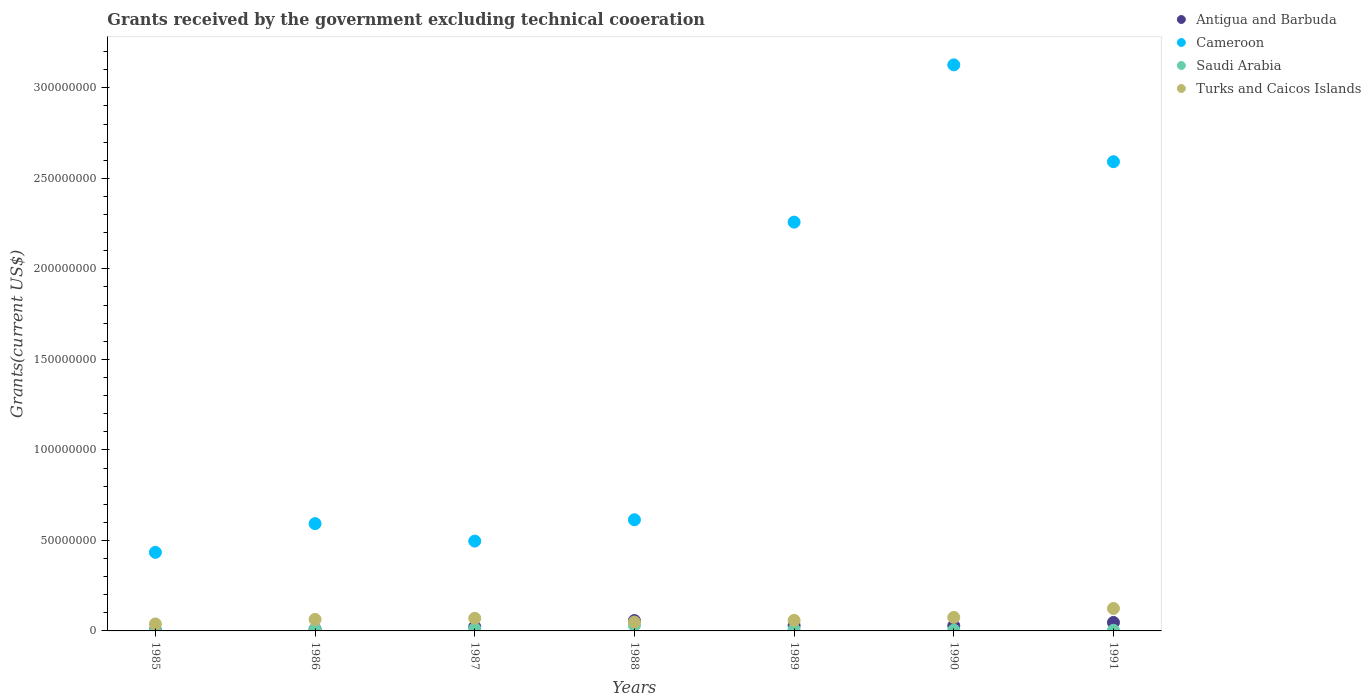How many different coloured dotlines are there?
Ensure brevity in your answer.  4. What is the total grants received by the government in Saudi Arabia in 1987?
Provide a short and direct response. 1.21e+06. Across all years, what is the maximum total grants received by the government in Cameroon?
Give a very brief answer. 3.13e+08. Across all years, what is the minimum total grants received by the government in Saudi Arabia?
Keep it short and to the point. 2.40e+05. In which year was the total grants received by the government in Turks and Caicos Islands minimum?
Offer a terse response. 1985. What is the total total grants received by the government in Saudi Arabia in the graph?
Make the answer very short. 6.97e+06. What is the difference between the total grants received by the government in Antigua and Barbuda in 1985 and that in 1990?
Your response must be concise. -2.38e+06. What is the difference between the total grants received by the government in Turks and Caicos Islands in 1990 and the total grants received by the government in Saudi Arabia in 1987?
Provide a succinct answer. 6.25e+06. What is the average total grants received by the government in Antigua and Barbuda per year?
Provide a short and direct response. 2.89e+06. In the year 1987, what is the difference between the total grants received by the government in Antigua and Barbuda and total grants received by the government in Turks and Caicos Islands?
Offer a terse response. -4.64e+06. What is the ratio of the total grants received by the government in Antigua and Barbuda in 1986 to that in 1990?
Make the answer very short. 0.37. What is the difference between the highest and the second highest total grants received by the government in Saudi Arabia?
Offer a very short reply. 1.82e+06. What is the difference between the highest and the lowest total grants received by the government in Turks and Caicos Islands?
Keep it short and to the point. 8.54e+06. In how many years, is the total grants received by the government in Antigua and Barbuda greater than the average total grants received by the government in Antigua and Barbuda taken over all years?
Ensure brevity in your answer.  3. Is the sum of the total grants received by the government in Turks and Caicos Islands in 1987 and 1991 greater than the maximum total grants received by the government in Antigua and Barbuda across all years?
Your response must be concise. Yes. Is it the case that in every year, the sum of the total grants received by the government in Turks and Caicos Islands and total grants received by the government in Antigua and Barbuda  is greater than the sum of total grants received by the government in Saudi Arabia and total grants received by the government in Cameroon?
Keep it short and to the point. No. Does the total grants received by the government in Saudi Arabia monotonically increase over the years?
Offer a terse response. No. Is the total grants received by the government in Saudi Arabia strictly greater than the total grants received by the government in Turks and Caicos Islands over the years?
Offer a very short reply. No. Is the total grants received by the government in Cameroon strictly less than the total grants received by the government in Saudi Arabia over the years?
Provide a short and direct response. No. How many dotlines are there?
Offer a very short reply. 4. How many years are there in the graph?
Offer a very short reply. 7. Does the graph contain any zero values?
Your response must be concise. No. What is the title of the graph?
Give a very brief answer. Grants received by the government excluding technical cooeration. What is the label or title of the Y-axis?
Your answer should be very brief. Grants(current US$). What is the Grants(current US$) of Cameroon in 1985?
Your answer should be very brief. 4.34e+07. What is the Grants(current US$) in Saudi Arabia in 1985?
Offer a terse response. 2.40e+05. What is the Grants(current US$) of Turks and Caicos Islands in 1985?
Your answer should be compact. 3.86e+06. What is the Grants(current US$) of Antigua and Barbuda in 1986?
Offer a terse response. 1.07e+06. What is the Grants(current US$) in Cameroon in 1986?
Offer a terse response. 5.93e+07. What is the Grants(current US$) of Saudi Arabia in 1986?
Provide a succinct answer. 9.30e+05. What is the Grants(current US$) of Turks and Caicos Islands in 1986?
Provide a short and direct response. 6.35e+06. What is the Grants(current US$) in Antigua and Barbuda in 1987?
Your response must be concise. 2.35e+06. What is the Grants(current US$) in Cameroon in 1987?
Your answer should be very brief. 4.96e+07. What is the Grants(current US$) of Saudi Arabia in 1987?
Keep it short and to the point. 1.21e+06. What is the Grants(current US$) in Turks and Caicos Islands in 1987?
Your answer should be very brief. 6.99e+06. What is the Grants(current US$) in Antigua and Barbuda in 1988?
Provide a short and direct response. 5.74e+06. What is the Grants(current US$) in Cameroon in 1988?
Provide a short and direct response. 6.14e+07. What is the Grants(current US$) of Saudi Arabia in 1988?
Keep it short and to the point. 3.03e+06. What is the Grants(current US$) in Turks and Caicos Islands in 1988?
Offer a very short reply. 4.90e+06. What is the Grants(current US$) of Antigua and Barbuda in 1989?
Your response must be concise. 2.97e+06. What is the Grants(current US$) of Cameroon in 1989?
Make the answer very short. 2.26e+08. What is the Grants(current US$) of Saudi Arabia in 1989?
Make the answer very short. 7.90e+05. What is the Grants(current US$) in Turks and Caicos Islands in 1989?
Offer a very short reply. 5.83e+06. What is the Grants(current US$) of Antigua and Barbuda in 1990?
Your response must be concise. 2.88e+06. What is the Grants(current US$) of Cameroon in 1990?
Ensure brevity in your answer.  3.13e+08. What is the Grants(current US$) in Turks and Caicos Islands in 1990?
Provide a short and direct response. 7.46e+06. What is the Grants(current US$) in Antigua and Barbuda in 1991?
Provide a succinct answer. 4.69e+06. What is the Grants(current US$) in Cameroon in 1991?
Keep it short and to the point. 2.59e+08. What is the Grants(current US$) of Turks and Caicos Islands in 1991?
Ensure brevity in your answer.  1.24e+07. Across all years, what is the maximum Grants(current US$) of Antigua and Barbuda?
Make the answer very short. 5.74e+06. Across all years, what is the maximum Grants(current US$) in Cameroon?
Make the answer very short. 3.13e+08. Across all years, what is the maximum Grants(current US$) of Saudi Arabia?
Offer a terse response. 3.03e+06. Across all years, what is the maximum Grants(current US$) in Turks and Caicos Islands?
Keep it short and to the point. 1.24e+07. Across all years, what is the minimum Grants(current US$) in Antigua and Barbuda?
Your response must be concise. 5.00e+05. Across all years, what is the minimum Grants(current US$) of Cameroon?
Your response must be concise. 4.34e+07. Across all years, what is the minimum Grants(current US$) in Saudi Arabia?
Offer a terse response. 2.40e+05. Across all years, what is the minimum Grants(current US$) of Turks and Caicos Islands?
Keep it short and to the point. 3.86e+06. What is the total Grants(current US$) of Antigua and Barbuda in the graph?
Make the answer very short. 2.02e+07. What is the total Grants(current US$) in Cameroon in the graph?
Your answer should be very brief. 1.01e+09. What is the total Grants(current US$) in Saudi Arabia in the graph?
Keep it short and to the point. 6.97e+06. What is the total Grants(current US$) of Turks and Caicos Islands in the graph?
Provide a short and direct response. 4.78e+07. What is the difference between the Grants(current US$) in Antigua and Barbuda in 1985 and that in 1986?
Offer a very short reply. -5.70e+05. What is the difference between the Grants(current US$) in Cameroon in 1985 and that in 1986?
Offer a very short reply. -1.59e+07. What is the difference between the Grants(current US$) in Saudi Arabia in 1985 and that in 1986?
Offer a terse response. -6.90e+05. What is the difference between the Grants(current US$) in Turks and Caicos Islands in 1985 and that in 1986?
Provide a succinct answer. -2.49e+06. What is the difference between the Grants(current US$) of Antigua and Barbuda in 1985 and that in 1987?
Offer a terse response. -1.85e+06. What is the difference between the Grants(current US$) of Cameroon in 1985 and that in 1987?
Your answer should be compact. -6.22e+06. What is the difference between the Grants(current US$) of Saudi Arabia in 1985 and that in 1987?
Ensure brevity in your answer.  -9.70e+05. What is the difference between the Grants(current US$) in Turks and Caicos Islands in 1985 and that in 1987?
Your answer should be very brief. -3.13e+06. What is the difference between the Grants(current US$) in Antigua and Barbuda in 1985 and that in 1988?
Keep it short and to the point. -5.24e+06. What is the difference between the Grants(current US$) of Cameroon in 1985 and that in 1988?
Your answer should be compact. -1.80e+07. What is the difference between the Grants(current US$) of Saudi Arabia in 1985 and that in 1988?
Your answer should be very brief. -2.79e+06. What is the difference between the Grants(current US$) in Turks and Caicos Islands in 1985 and that in 1988?
Make the answer very short. -1.04e+06. What is the difference between the Grants(current US$) of Antigua and Barbuda in 1985 and that in 1989?
Give a very brief answer. -2.47e+06. What is the difference between the Grants(current US$) in Cameroon in 1985 and that in 1989?
Make the answer very short. -1.82e+08. What is the difference between the Grants(current US$) in Saudi Arabia in 1985 and that in 1989?
Offer a very short reply. -5.50e+05. What is the difference between the Grants(current US$) of Turks and Caicos Islands in 1985 and that in 1989?
Offer a very short reply. -1.97e+06. What is the difference between the Grants(current US$) in Antigua and Barbuda in 1985 and that in 1990?
Give a very brief answer. -2.38e+06. What is the difference between the Grants(current US$) in Cameroon in 1985 and that in 1990?
Give a very brief answer. -2.69e+08. What is the difference between the Grants(current US$) of Turks and Caicos Islands in 1985 and that in 1990?
Your answer should be compact. -3.60e+06. What is the difference between the Grants(current US$) in Antigua and Barbuda in 1985 and that in 1991?
Provide a succinct answer. -4.19e+06. What is the difference between the Grants(current US$) in Cameroon in 1985 and that in 1991?
Offer a very short reply. -2.16e+08. What is the difference between the Grants(current US$) of Saudi Arabia in 1985 and that in 1991?
Offer a terse response. -1.00e+05. What is the difference between the Grants(current US$) of Turks and Caicos Islands in 1985 and that in 1991?
Keep it short and to the point. -8.54e+06. What is the difference between the Grants(current US$) in Antigua and Barbuda in 1986 and that in 1987?
Keep it short and to the point. -1.28e+06. What is the difference between the Grants(current US$) of Cameroon in 1986 and that in 1987?
Provide a succinct answer. 9.64e+06. What is the difference between the Grants(current US$) of Saudi Arabia in 1986 and that in 1987?
Provide a short and direct response. -2.80e+05. What is the difference between the Grants(current US$) of Turks and Caicos Islands in 1986 and that in 1987?
Offer a very short reply. -6.40e+05. What is the difference between the Grants(current US$) in Antigua and Barbuda in 1986 and that in 1988?
Offer a terse response. -4.67e+06. What is the difference between the Grants(current US$) of Cameroon in 1986 and that in 1988?
Make the answer very short. -2.14e+06. What is the difference between the Grants(current US$) in Saudi Arabia in 1986 and that in 1988?
Offer a terse response. -2.10e+06. What is the difference between the Grants(current US$) of Turks and Caicos Islands in 1986 and that in 1988?
Your answer should be compact. 1.45e+06. What is the difference between the Grants(current US$) of Antigua and Barbuda in 1986 and that in 1989?
Make the answer very short. -1.90e+06. What is the difference between the Grants(current US$) in Cameroon in 1986 and that in 1989?
Ensure brevity in your answer.  -1.67e+08. What is the difference between the Grants(current US$) in Saudi Arabia in 1986 and that in 1989?
Offer a very short reply. 1.40e+05. What is the difference between the Grants(current US$) in Turks and Caicos Islands in 1986 and that in 1989?
Make the answer very short. 5.20e+05. What is the difference between the Grants(current US$) in Antigua and Barbuda in 1986 and that in 1990?
Keep it short and to the point. -1.81e+06. What is the difference between the Grants(current US$) of Cameroon in 1986 and that in 1990?
Provide a succinct answer. -2.53e+08. What is the difference between the Grants(current US$) in Saudi Arabia in 1986 and that in 1990?
Make the answer very short. 5.00e+05. What is the difference between the Grants(current US$) of Turks and Caicos Islands in 1986 and that in 1990?
Give a very brief answer. -1.11e+06. What is the difference between the Grants(current US$) in Antigua and Barbuda in 1986 and that in 1991?
Ensure brevity in your answer.  -3.62e+06. What is the difference between the Grants(current US$) in Cameroon in 1986 and that in 1991?
Make the answer very short. -2.00e+08. What is the difference between the Grants(current US$) of Saudi Arabia in 1986 and that in 1991?
Provide a short and direct response. 5.90e+05. What is the difference between the Grants(current US$) of Turks and Caicos Islands in 1986 and that in 1991?
Give a very brief answer. -6.05e+06. What is the difference between the Grants(current US$) in Antigua and Barbuda in 1987 and that in 1988?
Offer a terse response. -3.39e+06. What is the difference between the Grants(current US$) in Cameroon in 1987 and that in 1988?
Give a very brief answer. -1.18e+07. What is the difference between the Grants(current US$) of Saudi Arabia in 1987 and that in 1988?
Offer a terse response. -1.82e+06. What is the difference between the Grants(current US$) of Turks and Caicos Islands in 1987 and that in 1988?
Your answer should be compact. 2.09e+06. What is the difference between the Grants(current US$) of Antigua and Barbuda in 1987 and that in 1989?
Make the answer very short. -6.20e+05. What is the difference between the Grants(current US$) of Cameroon in 1987 and that in 1989?
Your response must be concise. -1.76e+08. What is the difference between the Grants(current US$) of Turks and Caicos Islands in 1987 and that in 1989?
Keep it short and to the point. 1.16e+06. What is the difference between the Grants(current US$) in Antigua and Barbuda in 1987 and that in 1990?
Provide a succinct answer. -5.30e+05. What is the difference between the Grants(current US$) of Cameroon in 1987 and that in 1990?
Offer a very short reply. -2.63e+08. What is the difference between the Grants(current US$) of Saudi Arabia in 1987 and that in 1990?
Your response must be concise. 7.80e+05. What is the difference between the Grants(current US$) of Turks and Caicos Islands in 1987 and that in 1990?
Keep it short and to the point. -4.70e+05. What is the difference between the Grants(current US$) in Antigua and Barbuda in 1987 and that in 1991?
Provide a succinct answer. -2.34e+06. What is the difference between the Grants(current US$) in Cameroon in 1987 and that in 1991?
Ensure brevity in your answer.  -2.10e+08. What is the difference between the Grants(current US$) in Saudi Arabia in 1987 and that in 1991?
Keep it short and to the point. 8.70e+05. What is the difference between the Grants(current US$) in Turks and Caicos Islands in 1987 and that in 1991?
Your answer should be compact. -5.41e+06. What is the difference between the Grants(current US$) of Antigua and Barbuda in 1988 and that in 1989?
Your response must be concise. 2.77e+06. What is the difference between the Grants(current US$) in Cameroon in 1988 and that in 1989?
Keep it short and to the point. -1.64e+08. What is the difference between the Grants(current US$) of Saudi Arabia in 1988 and that in 1989?
Make the answer very short. 2.24e+06. What is the difference between the Grants(current US$) of Turks and Caicos Islands in 1988 and that in 1989?
Keep it short and to the point. -9.30e+05. What is the difference between the Grants(current US$) in Antigua and Barbuda in 1988 and that in 1990?
Offer a terse response. 2.86e+06. What is the difference between the Grants(current US$) in Cameroon in 1988 and that in 1990?
Your answer should be compact. -2.51e+08. What is the difference between the Grants(current US$) in Saudi Arabia in 1988 and that in 1990?
Offer a terse response. 2.60e+06. What is the difference between the Grants(current US$) of Turks and Caicos Islands in 1988 and that in 1990?
Offer a very short reply. -2.56e+06. What is the difference between the Grants(current US$) of Antigua and Barbuda in 1988 and that in 1991?
Your response must be concise. 1.05e+06. What is the difference between the Grants(current US$) in Cameroon in 1988 and that in 1991?
Your answer should be very brief. -1.98e+08. What is the difference between the Grants(current US$) in Saudi Arabia in 1988 and that in 1991?
Your answer should be very brief. 2.69e+06. What is the difference between the Grants(current US$) in Turks and Caicos Islands in 1988 and that in 1991?
Your response must be concise. -7.50e+06. What is the difference between the Grants(current US$) in Cameroon in 1989 and that in 1990?
Offer a terse response. -8.69e+07. What is the difference between the Grants(current US$) in Saudi Arabia in 1989 and that in 1990?
Give a very brief answer. 3.60e+05. What is the difference between the Grants(current US$) of Turks and Caicos Islands in 1989 and that in 1990?
Offer a terse response. -1.63e+06. What is the difference between the Grants(current US$) in Antigua and Barbuda in 1989 and that in 1991?
Your answer should be compact. -1.72e+06. What is the difference between the Grants(current US$) in Cameroon in 1989 and that in 1991?
Provide a succinct answer. -3.34e+07. What is the difference between the Grants(current US$) in Turks and Caicos Islands in 1989 and that in 1991?
Ensure brevity in your answer.  -6.57e+06. What is the difference between the Grants(current US$) of Antigua and Barbuda in 1990 and that in 1991?
Ensure brevity in your answer.  -1.81e+06. What is the difference between the Grants(current US$) in Cameroon in 1990 and that in 1991?
Your answer should be very brief. 5.35e+07. What is the difference between the Grants(current US$) of Saudi Arabia in 1990 and that in 1991?
Make the answer very short. 9.00e+04. What is the difference between the Grants(current US$) in Turks and Caicos Islands in 1990 and that in 1991?
Give a very brief answer. -4.94e+06. What is the difference between the Grants(current US$) in Antigua and Barbuda in 1985 and the Grants(current US$) in Cameroon in 1986?
Provide a succinct answer. -5.88e+07. What is the difference between the Grants(current US$) in Antigua and Barbuda in 1985 and the Grants(current US$) in Saudi Arabia in 1986?
Ensure brevity in your answer.  -4.30e+05. What is the difference between the Grants(current US$) in Antigua and Barbuda in 1985 and the Grants(current US$) in Turks and Caicos Islands in 1986?
Your response must be concise. -5.85e+06. What is the difference between the Grants(current US$) of Cameroon in 1985 and the Grants(current US$) of Saudi Arabia in 1986?
Give a very brief answer. 4.25e+07. What is the difference between the Grants(current US$) of Cameroon in 1985 and the Grants(current US$) of Turks and Caicos Islands in 1986?
Your answer should be very brief. 3.71e+07. What is the difference between the Grants(current US$) in Saudi Arabia in 1985 and the Grants(current US$) in Turks and Caicos Islands in 1986?
Provide a short and direct response. -6.11e+06. What is the difference between the Grants(current US$) of Antigua and Barbuda in 1985 and the Grants(current US$) of Cameroon in 1987?
Provide a short and direct response. -4.91e+07. What is the difference between the Grants(current US$) in Antigua and Barbuda in 1985 and the Grants(current US$) in Saudi Arabia in 1987?
Offer a very short reply. -7.10e+05. What is the difference between the Grants(current US$) in Antigua and Barbuda in 1985 and the Grants(current US$) in Turks and Caicos Islands in 1987?
Provide a short and direct response. -6.49e+06. What is the difference between the Grants(current US$) in Cameroon in 1985 and the Grants(current US$) in Saudi Arabia in 1987?
Give a very brief answer. 4.22e+07. What is the difference between the Grants(current US$) in Cameroon in 1985 and the Grants(current US$) in Turks and Caicos Islands in 1987?
Make the answer very short. 3.64e+07. What is the difference between the Grants(current US$) in Saudi Arabia in 1985 and the Grants(current US$) in Turks and Caicos Islands in 1987?
Your answer should be compact. -6.75e+06. What is the difference between the Grants(current US$) in Antigua and Barbuda in 1985 and the Grants(current US$) in Cameroon in 1988?
Ensure brevity in your answer.  -6.09e+07. What is the difference between the Grants(current US$) of Antigua and Barbuda in 1985 and the Grants(current US$) of Saudi Arabia in 1988?
Keep it short and to the point. -2.53e+06. What is the difference between the Grants(current US$) in Antigua and Barbuda in 1985 and the Grants(current US$) in Turks and Caicos Islands in 1988?
Your answer should be compact. -4.40e+06. What is the difference between the Grants(current US$) in Cameroon in 1985 and the Grants(current US$) in Saudi Arabia in 1988?
Give a very brief answer. 4.04e+07. What is the difference between the Grants(current US$) of Cameroon in 1985 and the Grants(current US$) of Turks and Caicos Islands in 1988?
Ensure brevity in your answer.  3.85e+07. What is the difference between the Grants(current US$) in Saudi Arabia in 1985 and the Grants(current US$) in Turks and Caicos Islands in 1988?
Your answer should be very brief. -4.66e+06. What is the difference between the Grants(current US$) in Antigua and Barbuda in 1985 and the Grants(current US$) in Cameroon in 1989?
Make the answer very short. -2.25e+08. What is the difference between the Grants(current US$) in Antigua and Barbuda in 1985 and the Grants(current US$) in Turks and Caicos Islands in 1989?
Give a very brief answer. -5.33e+06. What is the difference between the Grants(current US$) of Cameroon in 1985 and the Grants(current US$) of Saudi Arabia in 1989?
Offer a terse response. 4.26e+07. What is the difference between the Grants(current US$) in Cameroon in 1985 and the Grants(current US$) in Turks and Caicos Islands in 1989?
Your answer should be compact. 3.76e+07. What is the difference between the Grants(current US$) in Saudi Arabia in 1985 and the Grants(current US$) in Turks and Caicos Islands in 1989?
Your answer should be very brief. -5.59e+06. What is the difference between the Grants(current US$) in Antigua and Barbuda in 1985 and the Grants(current US$) in Cameroon in 1990?
Provide a short and direct response. -3.12e+08. What is the difference between the Grants(current US$) in Antigua and Barbuda in 1985 and the Grants(current US$) in Turks and Caicos Islands in 1990?
Your answer should be compact. -6.96e+06. What is the difference between the Grants(current US$) of Cameroon in 1985 and the Grants(current US$) of Saudi Arabia in 1990?
Offer a terse response. 4.30e+07. What is the difference between the Grants(current US$) in Cameroon in 1985 and the Grants(current US$) in Turks and Caicos Islands in 1990?
Offer a terse response. 3.60e+07. What is the difference between the Grants(current US$) of Saudi Arabia in 1985 and the Grants(current US$) of Turks and Caicos Islands in 1990?
Keep it short and to the point. -7.22e+06. What is the difference between the Grants(current US$) in Antigua and Barbuda in 1985 and the Grants(current US$) in Cameroon in 1991?
Your response must be concise. -2.59e+08. What is the difference between the Grants(current US$) of Antigua and Barbuda in 1985 and the Grants(current US$) of Turks and Caicos Islands in 1991?
Provide a short and direct response. -1.19e+07. What is the difference between the Grants(current US$) of Cameroon in 1985 and the Grants(current US$) of Saudi Arabia in 1991?
Your answer should be compact. 4.31e+07. What is the difference between the Grants(current US$) in Cameroon in 1985 and the Grants(current US$) in Turks and Caicos Islands in 1991?
Your answer should be compact. 3.10e+07. What is the difference between the Grants(current US$) of Saudi Arabia in 1985 and the Grants(current US$) of Turks and Caicos Islands in 1991?
Provide a succinct answer. -1.22e+07. What is the difference between the Grants(current US$) in Antigua and Barbuda in 1986 and the Grants(current US$) in Cameroon in 1987?
Give a very brief answer. -4.86e+07. What is the difference between the Grants(current US$) of Antigua and Barbuda in 1986 and the Grants(current US$) of Saudi Arabia in 1987?
Provide a short and direct response. -1.40e+05. What is the difference between the Grants(current US$) in Antigua and Barbuda in 1986 and the Grants(current US$) in Turks and Caicos Islands in 1987?
Offer a very short reply. -5.92e+06. What is the difference between the Grants(current US$) of Cameroon in 1986 and the Grants(current US$) of Saudi Arabia in 1987?
Ensure brevity in your answer.  5.81e+07. What is the difference between the Grants(current US$) of Cameroon in 1986 and the Grants(current US$) of Turks and Caicos Islands in 1987?
Ensure brevity in your answer.  5.23e+07. What is the difference between the Grants(current US$) of Saudi Arabia in 1986 and the Grants(current US$) of Turks and Caicos Islands in 1987?
Offer a terse response. -6.06e+06. What is the difference between the Grants(current US$) in Antigua and Barbuda in 1986 and the Grants(current US$) in Cameroon in 1988?
Your answer should be very brief. -6.03e+07. What is the difference between the Grants(current US$) of Antigua and Barbuda in 1986 and the Grants(current US$) of Saudi Arabia in 1988?
Keep it short and to the point. -1.96e+06. What is the difference between the Grants(current US$) in Antigua and Barbuda in 1986 and the Grants(current US$) in Turks and Caicos Islands in 1988?
Provide a short and direct response. -3.83e+06. What is the difference between the Grants(current US$) in Cameroon in 1986 and the Grants(current US$) in Saudi Arabia in 1988?
Offer a very short reply. 5.62e+07. What is the difference between the Grants(current US$) in Cameroon in 1986 and the Grants(current US$) in Turks and Caicos Islands in 1988?
Provide a succinct answer. 5.44e+07. What is the difference between the Grants(current US$) in Saudi Arabia in 1986 and the Grants(current US$) in Turks and Caicos Islands in 1988?
Provide a succinct answer. -3.97e+06. What is the difference between the Grants(current US$) in Antigua and Barbuda in 1986 and the Grants(current US$) in Cameroon in 1989?
Provide a short and direct response. -2.25e+08. What is the difference between the Grants(current US$) in Antigua and Barbuda in 1986 and the Grants(current US$) in Saudi Arabia in 1989?
Ensure brevity in your answer.  2.80e+05. What is the difference between the Grants(current US$) of Antigua and Barbuda in 1986 and the Grants(current US$) of Turks and Caicos Islands in 1989?
Provide a succinct answer. -4.76e+06. What is the difference between the Grants(current US$) in Cameroon in 1986 and the Grants(current US$) in Saudi Arabia in 1989?
Your answer should be compact. 5.85e+07. What is the difference between the Grants(current US$) of Cameroon in 1986 and the Grants(current US$) of Turks and Caicos Islands in 1989?
Ensure brevity in your answer.  5.34e+07. What is the difference between the Grants(current US$) of Saudi Arabia in 1986 and the Grants(current US$) of Turks and Caicos Islands in 1989?
Provide a succinct answer. -4.90e+06. What is the difference between the Grants(current US$) of Antigua and Barbuda in 1986 and the Grants(current US$) of Cameroon in 1990?
Your response must be concise. -3.12e+08. What is the difference between the Grants(current US$) in Antigua and Barbuda in 1986 and the Grants(current US$) in Saudi Arabia in 1990?
Offer a very short reply. 6.40e+05. What is the difference between the Grants(current US$) in Antigua and Barbuda in 1986 and the Grants(current US$) in Turks and Caicos Islands in 1990?
Ensure brevity in your answer.  -6.39e+06. What is the difference between the Grants(current US$) of Cameroon in 1986 and the Grants(current US$) of Saudi Arabia in 1990?
Your answer should be very brief. 5.88e+07. What is the difference between the Grants(current US$) of Cameroon in 1986 and the Grants(current US$) of Turks and Caicos Islands in 1990?
Your answer should be very brief. 5.18e+07. What is the difference between the Grants(current US$) of Saudi Arabia in 1986 and the Grants(current US$) of Turks and Caicos Islands in 1990?
Keep it short and to the point. -6.53e+06. What is the difference between the Grants(current US$) in Antigua and Barbuda in 1986 and the Grants(current US$) in Cameroon in 1991?
Your answer should be compact. -2.58e+08. What is the difference between the Grants(current US$) of Antigua and Barbuda in 1986 and the Grants(current US$) of Saudi Arabia in 1991?
Provide a succinct answer. 7.30e+05. What is the difference between the Grants(current US$) in Antigua and Barbuda in 1986 and the Grants(current US$) in Turks and Caicos Islands in 1991?
Your answer should be compact. -1.13e+07. What is the difference between the Grants(current US$) in Cameroon in 1986 and the Grants(current US$) in Saudi Arabia in 1991?
Make the answer very short. 5.89e+07. What is the difference between the Grants(current US$) of Cameroon in 1986 and the Grants(current US$) of Turks and Caicos Islands in 1991?
Make the answer very short. 4.69e+07. What is the difference between the Grants(current US$) in Saudi Arabia in 1986 and the Grants(current US$) in Turks and Caicos Islands in 1991?
Give a very brief answer. -1.15e+07. What is the difference between the Grants(current US$) of Antigua and Barbuda in 1987 and the Grants(current US$) of Cameroon in 1988?
Keep it short and to the point. -5.91e+07. What is the difference between the Grants(current US$) in Antigua and Barbuda in 1987 and the Grants(current US$) in Saudi Arabia in 1988?
Your answer should be very brief. -6.80e+05. What is the difference between the Grants(current US$) of Antigua and Barbuda in 1987 and the Grants(current US$) of Turks and Caicos Islands in 1988?
Your response must be concise. -2.55e+06. What is the difference between the Grants(current US$) of Cameroon in 1987 and the Grants(current US$) of Saudi Arabia in 1988?
Offer a very short reply. 4.66e+07. What is the difference between the Grants(current US$) of Cameroon in 1987 and the Grants(current US$) of Turks and Caicos Islands in 1988?
Offer a terse response. 4.47e+07. What is the difference between the Grants(current US$) in Saudi Arabia in 1987 and the Grants(current US$) in Turks and Caicos Islands in 1988?
Keep it short and to the point. -3.69e+06. What is the difference between the Grants(current US$) of Antigua and Barbuda in 1987 and the Grants(current US$) of Cameroon in 1989?
Provide a short and direct response. -2.23e+08. What is the difference between the Grants(current US$) of Antigua and Barbuda in 1987 and the Grants(current US$) of Saudi Arabia in 1989?
Provide a succinct answer. 1.56e+06. What is the difference between the Grants(current US$) in Antigua and Barbuda in 1987 and the Grants(current US$) in Turks and Caicos Islands in 1989?
Offer a terse response. -3.48e+06. What is the difference between the Grants(current US$) of Cameroon in 1987 and the Grants(current US$) of Saudi Arabia in 1989?
Offer a very short reply. 4.88e+07. What is the difference between the Grants(current US$) in Cameroon in 1987 and the Grants(current US$) in Turks and Caicos Islands in 1989?
Your answer should be very brief. 4.38e+07. What is the difference between the Grants(current US$) of Saudi Arabia in 1987 and the Grants(current US$) of Turks and Caicos Islands in 1989?
Your answer should be very brief. -4.62e+06. What is the difference between the Grants(current US$) in Antigua and Barbuda in 1987 and the Grants(current US$) in Cameroon in 1990?
Offer a terse response. -3.10e+08. What is the difference between the Grants(current US$) in Antigua and Barbuda in 1987 and the Grants(current US$) in Saudi Arabia in 1990?
Ensure brevity in your answer.  1.92e+06. What is the difference between the Grants(current US$) in Antigua and Barbuda in 1987 and the Grants(current US$) in Turks and Caicos Islands in 1990?
Ensure brevity in your answer.  -5.11e+06. What is the difference between the Grants(current US$) of Cameroon in 1987 and the Grants(current US$) of Saudi Arabia in 1990?
Your answer should be compact. 4.92e+07. What is the difference between the Grants(current US$) of Cameroon in 1987 and the Grants(current US$) of Turks and Caicos Islands in 1990?
Offer a very short reply. 4.22e+07. What is the difference between the Grants(current US$) in Saudi Arabia in 1987 and the Grants(current US$) in Turks and Caicos Islands in 1990?
Your answer should be compact. -6.25e+06. What is the difference between the Grants(current US$) of Antigua and Barbuda in 1987 and the Grants(current US$) of Cameroon in 1991?
Provide a short and direct response. -2.57e+08. What is the difference between the Grants(current US$) in Antigua and Barbuda in 1987 and the Grants(current US$) in Saudi Arabia in 1991?
Your response must be concise. 2.01e+06. What is the difference between the Grants(current US$) in Antigua and Barbuda in 1987 and the Grants(current US$) in Turks and Caicos Islands in 1991?
Your response must be concise. -1.00e+07. What is the difference between the Grants(current US$) in Cameroon in 1987 and the Grants(current US$) in Saudi Arabia in 1991?
Your answer should be very brief. 4.93e+07. What is the difference between the Grants(current US$) of Cameroon in 1987 and the Grants(current US$) of Turks and Caicos Islands in 1991?
Your response must be concise. 3.72e+07. What is the difference between the Grants(current US$) of Saudi Arabia in 1987 and the Grants(current US$) of Turks and Caicos Islands in 1991?
Offer a very short reply. -1.12e+07. What is the difference between the Grants(current US$) of Antigua and Barbuda in 1988 and the Grants(current US$) of Cameroon in 1989?
Offer a very short reply. -2.20e+08. What is the difference between the Grants(current US$) of Antigua and Barbuda in 1988 and the Grants(current US$) of Saudi Arabia in 1989?
Ensure brevity in your answer.  4.95e+06. What is the difference between the Grants(current US$) of Antigua and Barbuda in 1988 and the Grants(current US$) of Turks and Caicos Islands in 1989?
Offer a very short reply. -9.00e+04. What is the difference between the Grants(current US$) of Cameroon in 1988 and the Grants(current US$) of Saudi Arabia in 1989?
Your answer should be very brief. 6.06e+07. What is the difference between the Grants(current US$) in Cameroon in 1988 and the Grants(current US$) in Turks and Caicos Islands in 1989?
Offer a terse response. 5.56e+07. What is the difference between the Grants(current US$) of Saudi Arabia in 1988 and the Grants(current US$) of Turks and Caicos Islands in 1989?
Give a very brief answer. -2.80e+06. What is the difference between the Grants(current US$) in Antigua and Barbuda in 1988 and the Grants(current US$) in Cameroon in 1990?
Your answer should be compact. -3.07e+08. What is the difference between the Grants(current US$) in Antigua and Barbuda in 1988 and the Grants(current US$) in Saudi Arabia in 1990?
Make the answer very short. 5.31e+06. What is the difference between the Grants(current US$) of Antigua and Barbuda in 1988 and the Grants(current US$) of Turks and Caicos Islands in 1990?
Provide a succinct answer. -1.72e+06. What is the difference between the Grants(current US$) of Cameroon in 1988 and the Grants(current US$) of Saudi Arabia in 1990?
Offer a terse response. 6.10e+07. What is the difference between the Grants(current US$) of Cameroon in 1988 and the Grants(current US$) of Turks and Caicos Islands in 1990?
Make the answer very short. 5.40e+07. What is the difference between the Grants(current US$) in Saudi Arabia in 1988 and the Grants(current US$) in Turks and Caicos Islands in 1990?
Your answer should be very brief. -4.43e+06. What is the difference between the Grants(current US$) of Antigua and Barbuda in 1988 and the Grants(current US$) of Cameroon in 1991?
Keep it short and to the point. -2.53e+08. What is the difference between the Grants(current US$) in Antigua and Barbuda in 1988 and the Grants(current US$) in Saudi Arabia in 1991?
Your answer should be compact. 5.40e+06. What is the difference between the Grants(current US$) of Antigua and Barbuda in 1988 and the Grants(current US$) of Turks and Caicos Islands in 1991?
Make the answer very short. -6.66e+06. What is the difference between the Grants(current US$) of Cameroon in 1988 and the Grants(current US$) of Saudi Arabia in 1991?
Provide a succinct answer. 6.11e+07. What is the difference between the Grants(current US$) in Cameroon in 1988 and the Grants(current US$) in Turks and Caicos Islands in 1991?
Ensure brevity in your answer.  4.90e+07. What is the difference between the Grants(current US$) in Saudi Arabia in 1988 and the Grants(current US$) in Turks and Caicos Islands in 1991?
Keep it short and to the point. -9.37e+06. What is the difference between the Grants(current US$) in Antigua and Barbuda in 1989 and the Grants(current US$) in Cameroon in 1990?
Your response must be concise. -3.10e+08. What is the difference between the Grants(current US$) in Antigua and Barbuda in 1989 and the Grants(current US$) in Saudi Arabia in 1990?
Provide a succinct answer. 2.54e+06. What is the difference between the Grants(current US$) in Antigua and Barbuda in 1989 and the Grants(current US$) in Turks and Caicos Islands in 1990?
Keep it short and to the point. -4.49e+06. What is the difference between the Grants(current US$) of Cameroon in 1989 and the Grants(current US$) of Saudi Arabia in 1990?
Give a very brief answer. 2.25e+08. What is the difference between the Grants(current US$) in Cameroon in 1989 and the Grants(current US$) in Turks and Caicos Islands in 1990?
Make the answer very short. 2.18e+08. What is the difference between the Grants(current US$) of Saudi Arabia in 1989 and the Grants(current US$) of Turks and Caicos Islands in 1990?
Provide a succinct answer. -6.67e+06. What is the difference between the Grants(current US$) in Antigua and Barbuda in 1989 and the Grants(current US$) in Cameroon in 1991?
Give a very brief answer. -2.56e+08. What is the difference between the Grants(current US$) in Antigua and Barbuda in 1989 and the Grants(current US$) in Saudi Arabia in 1991?
Give a very brief answer. 2.63e+06. What is the difference between the Grants(current US$) in Antigua and Barbuda in 1989 and the Grants(current US$) in Turks and Caicos Islands in 1991?
Your answer should be compact. -9.43e+06. What is the difference between the Grants(current US$) in Cameroon in 1989 and the Grants(current US$) in Saudi Arabia in 1991?
Make the answer very short. 2.25e+08. What is the difference between the Grants(current US$) in Cameroon in 1989 and the Grants(current US$) in Turks and Caicos Islands in 1991?
Offer a terse response. 2.13e+08. What is the difference between the Grants(current US$) of Saudi Arabia in 1989 and the Grants(current US$) of Turks and Caicos Islands in 1991?
Give a very brief answer. -1.16e+07. What is the difference between the Grants(current US$) of Antigua and Barbuda in 1990 and the Grants(current US$) of Cameroon in 1991?
Make the answer very short. -2.56e+08. What is the difference between the Grants(current US$) in Antigua and Barbuda in 1990 and the Grants(current US$) in Saudi Arabia in 1991?
Provide a short and direct response. 2.54e+06. What is the difference between the Grants(current US$) in Antigua and Barbuda in 1990 and the Grants(current US$) in Turks and Caicos Islands in 1991?
Keep it short and to the point. -9.52e+06. What is the difference between the Grants(current US$) in Cameroon in 1990 and the Grants(current US$) in Saudi Arabia in 1991?
Your answer should be very brief. 3.12e+08. What is the difference between the Grants(current US$) of Cameroon in 1990 and the Grants(current US$) of Turks and Caicos Islands in 1991?
Give a very brief answer. 3.00e+08. What is the difference between the Grants(current US$) in Saudi Arabia in 1990 and the Grants(current US$) in Turks and Caicos Islands in 1991?
Your answer should be very brief. -1.20e+07. What is the average Grants(current US$) of Antigua and Barbuda per year?
Keep it short and to the point. 2.89e+06. What is the average Grants(current US$) in Cameroon per year?
Make the answer very short. 1.44e+08. What is the average Grants(current US$) of Saudi Arabia per year?
Your answer should be very brief. 9.96e+05. What is the average Grants(current US$) of Turks and Caicos Islands per year?
Your response must be concise. 6.83e+06. In the year 1985, what is the difference between the Grants(current US$) in Antigua and Barbuda and Grants(current US$) in Cameroon?
Give a very brief answer. -4.29e+07. In the year 1985, what is the difference between the Grants(current US$) in Antigua and Barbuda and Grants(current US$) in Turks and Caicos Islands?
Keep it short and to the point. -3.36e+06. In the year 1985, what is the difference between the Grants(current US$) in Cameroon and Grants(current US$) in Saudi Arabia?
Your response must be concise. 4.32e+07. In the year 1985, what is the difference between the Grants(current US$) of Cameroon and Grants(current US$) of Turks and Caicos Islands?
Provide a succinct answer. 3.96e+07. In the year 1985, what is the difference between the Grants(current US$) of Saudi Arabia and Grants(current US$) of Turks and Caicos Islands?
Offer a very short reply. -3.62e+06. In the year 1986, what is the difference between the Grants(current US$) in Antigua and Barbuda and Grants(current US$) in Cameroon?
Give a very brief answer. -5.82e+07. In the year 1986, what is the difference between the Grants(current US$) of Antigua and Barbuda and Grants(current US$) of Saudi Arabia?
Your answer should be very brief. 1.40e+05. In the year 1986, what is the difference between the Grants(current US$) of Antigua and Barbuda and Grants(current US$) of Turks and Caicos Islands?
Give a very brief answer. -5.28e+06. In the year 1986, what is the difference between the Grants(current US$) of Cameroon and Grants(current US$) of Saudi Arabia?
Offer a terse response. 5.83e+07. In the year 1986, what is the difference between the Grants(current US$) in Cameroon and Grants(current US$) in Turks and Caicos Islands?
Give a very brief answer. 5.29e+07. In the year 1986, what is the difference between the Grants(current US$) of Saudi Arabia and Grants(current US$) of Turks and Caicos Islands?
Ensure brevity in your answer.  -5.42e+06. In the year 1987, what is the difference between the Grants(current US$) in Antigua and Barbuda and Grants(current US$) in Cameroon?
Offer a terse response. -4.73e+07. In the year 1987, what is the difference between the Grants(current US$) of Antigua and Barbuda and Grants(current US$) of Saudi Arabia?
Give a very brief answer. 1.14e+06. In the year 1987, what is the difference between the Grants(current US$) in Antigua and Barbuda and Grants(current US$) in Turks and Caicos Islands?
Your response must be concise. -4.64e+06. In the year 1987, what is the difference between the Grants(current US$) of Cameroon and Grants(current US$) of Saudi Arabia?
Keep it short and to the point. 4.84e+07. In the year 1987, what is the difference between the Grants(current US$) of Cameroon and Grants(current US$) of Turks and Caicos Islands?
Provide a succinct answer. 4.26e+07. In the year 1987, what is the difference between the Grants(current US$) of Saudi Arabia and Grants(current US$) of Turks and Caicos Islands?
Offer a terse response. -5.78e+06. In the year 1988, what is the difference between the Grants(current US$) of Antigua and Barbuda and Grants(current US$) of Cameroon?
Give a very brief answer. -5.57e+07. In the year 1988, what is the difference between the Grants(current US$) of Antigua and Barbuda and Grants(current US$) of Saudi Arabia?
Your answer should be compact. 2.71e+06. In the year 1988, what is the difference between the Grants(current US$) of Antigua and Barbuda and Grants(current US$) of Turks and Caicos Islands?
Your answer should be very brief. 8.40e+05. In the year 1988, what is the difference between the Grants(current US$) in Cameroon and Grants(current US$) in Saudi Arabia?
Keep it short and to the point. 5.84e+07. In the year 1988, what is the difference between the Grants(current US$) in Cameroon and Grants(current US$) in Turks and Caicos Islands?
Offer a very short reply. 5.65e+07. In the year 1988, what is the difference between the Grants(current US$) in Saudi Arabia and Grants(current US$) in Turks and Caicos Islands?
Your response must be concise. -1.87e+06. In the year 1989, what is the difference between the Grants(current US$) in Antigua and Barbuda and Grants(current US$) in Cameroon?
Provide a short and direct response. -2.23e+08. In the year 1989, what is the difference between the Grants(current US$) of Antigua and Barbuda and Grants(current US$) of Saudi Arabia?
Offer a terse response. 2.18e+06. In the year 1989, what is the difference between the Grants(current US$) of Antigua and Barbuda and Grants(current US$) of Turks and Caicos Islands?
Ensure brevity in your answer.  -2.86e+06. In the year 1989, what is the difference between the Grants(current US$) of Cameroon and Grants(current US$) of Saudi Arabia?
Your answer should be compact. 2.25e+08. In the year 1989, what is the difference between the Grants(current US$) in Cameroon and Grants(current US$) in Turks and Caicos Islands?
Keep it short and to the point. 2.20e+08. In the year 1989, what is the difference between the Grants(current US$) of Saudi Arabia and Grants(current US$) of Turks and Caicos Islands?
Your answer should be very brief. -5.04e+06. In the year 1990, what is the difference between the Grants(current US$) in Antigua and Barbuda and Grants(current US$) in Cameroon?
Provide a short and direct response. -3.10e+08. In the year 1990, what is the difference between the Grants(current US$) in Antigua and Barbuda and Grants(current US$) in Saudi Arabia?
Provide a succinct answer. 2.45e+06. In the year 1990, what is the difference between the Grants(current US$) of Antigua and Barbuda and Grants(current US$) of Turks and Caicos Islands?
Provide a succinct answer. -4.58e+06. In the year 1990, what is the difference between the Grants(current US$) of Cameroon and Grants(current US$) of Saudi Arabia?
Your answer should be compact. 3.12e+08. In the year 1990, what is the difference between the Grants(current US$) in Cameroon and Grants(current US$) in Turks and Caicos Islands?
Offer a very short reply. 3.05e+08. In the year 1990, what is the difference between the Grants(current US$) of Saudi Arabia and Grants(current US$) of Turks and Caicos Islands?
Offer a very short reply. -7.03e+06. In the year 1991, what is the difference between the Grants(current US$) in Antigua and Barbuda and Grants(current US$) in Cameroon?
Make the answer very short. -2.55e+08. In the year 1991, what is the difference between the Grants(current US$) of Antigua and Barbuda and Grants(current US$) of Saudi Arabia?
Provide a succinct answer. 4.35e+06. In the year 1991, what is the difference between the Grants(current US$) of Antigua and Barbuda and Grants(current US$) of Turks and Caicos Islands?
Give a very brief answer. -7.71e+06. In the year 1991, what is the difference between the Grants(current US$) of Cameroon and Grants(current US$) of Saudi Arabia?
Your answer should be very brief. 2.59e+08. In the year 1991, what is the difference between the Grants(current US$) in Cameroon and Grants(current US$) in Turks and Caicos Islands?
Your answer should be very brief. 2.47e+08. In the year 1991, what is the difference between the Grants(current US$) of Saudi Arabia and Grants(current US$) of Turks and Caicos Islands?
Your response must be concise. -1.21e+07. What is the ratio of the Grants(current US$) in Antigua and Barbuda in 1985 to that in 1986?
Give a very brief answer. 0.47. What is the ratio of the Grants(current US$) in Cameroon in 1985 to that in 1986?
Your answer should be very brief. 0.73. What is the ratio of the Grants(current US$) in Saudi Arabia in 1985 to that in 1986?
Ensure brevity in your answer.  0.26. What is the ratio of the Grants(current US$) in Turks and Caicos Islands in 1985 to that in 1986?
Your answer should be compact. 0.61. What is the ratio of the Grants(current US$) in Antigua and Barbuda in 1985 to that in 1987?
Give a very brief answer. 0.21. What is the ratio of the Grants(current US$) in Cameroon in 1985 to that in 1987?
Provide a short and direct response. 0.87. What is the ratio of the Grants(current US$) of Saudi Arabia in 1985 to that in 1987?
Ensure brevity in your answer.  0.2. What is the ratio of the Grants(current US$) in Turks and Caicos Islands in 1985 to that in 1987?
Offer a terse response. 0.55. What is the ratio of the Grants(current US$) of Antigua and Barbuda in 1985 to that in 1988?
Your response must be concise. 0.09. What is the ratio of the Grants(current US$) of Cameroon in 1985 to that in 1988?
Provide a succinct answer. 0.71. What is the ratio of the Grants(current US$) in Saudi Arabia in 1985 to that in 1988?
Offer a very short reply. 0.08. What is the ratio of the Grants(current US$) in Turks and Caicos Islands in 1985 to that in 1988?
Your response must be concise. 0.79. What is the ratio of the Grants(current US$) in Antigua and Barbuda in 1985 to that in 1989?
Ensure brevity in your answer.  0.17. What is the ratio of the Grants(current US$) of Cameroon in 1985 to that in 1989?
Offer a terse response. 0.19. What is the ratio of the Grants(current US$) in Saudi Arabia in 1985 to that in 1989?
Offer a very short reply. 0.3. What is the ratio of the Grants(current US$) of Turks and Caicos Islands in 1985 to that in 1989?
Your response must be concise. 0.66. What is the ratio of the Grants(current US$) of Antigua and Barbuda in 1985 to that in 1990?
Offer a very short reply. 0.17. What is the ratio of the Grants(current US$) in Cameroon in 1985 to that in 1990?
Keep it short and to the point. 0.14. What is the ratio of the Grants(current US$) of Saudi Arabia in 1985 to that in 1990?
Make the answer very short. 0.56. What is the ratio of the Grants(current US$) of Turks and Caicos Islands in 1985 to that in 1990?
Offer a very short reply. 0.52. What is the ratio of the Grants(current US$) in Antigua and Barbuda in 1985 to that in 1991?
Make the answer very short. 0.11. What is the ratio of the Grants(current US$) of Cameroon in 1985 to that in 1991?
Your response must be concise. 0.17. What is the ratio of the Grants(current US$) in Saudi Arabia in 1985 to that in 1991?
Provide a succinct answer. 0.71. What is the ratio of the Grants(current US$) in Turks and Caicos Islands in 1985 to that in 1991?
Your answer should be compact. 0.31. What is the ratio of the Grants(current US$) of Antigua and Barbuda in 1986 to that in 1987?
Give a very brief answer. 0.46. What is the ratio of the Grants(current US$) in Cameroon in 1986 to that in 1987?
Offer a terse response. 1.19. What is the ratio of the Grants(current US$) in Saudi Arabia in 1986 to that in 1987?
Keep it short and to the point. 0.77. What is the ratio of the Grants(current US$) in Turks and Caicos Islands in 1986 to that in 1987?
Provide a short and direct response. 0.91. What is the ratio of the Grants(current US$) of Antigua and Barbuda in 1986 to that in 1988?
Your answer should be compact. 0.19. What is the ratio of the Grants(current US$) of Cameroon in 1986 to that in 1988?
Give a very brief answer. 0.97. What is the ratio of the Grants(current US$) of Saudi Arabia in 1986 to that in 1988?
Offer a very short reply. 0.31. What is the ratio of the Grants(current US$) of Turks and Caicos Islands in 1986 to that in 1988?
Offer a terse response. 1.3. What is the ratio of the Grants(current US$) in Antigua and Barbuda in 1986 to that in 1989?
Ensure brevity in your answer.  0.36. What is the ratio of the Grants(current US$) in Cameroon in 1986 to that in 1989?
Your answer should be very brief. 0.26. What is the ratio of the Grants(current US$) in Saudi Arabia in 1986 to that in 1989?
Ensure brevity in your answer.  1.18. What is the ratio of the Grants(current US$) of Turks and Caicos Islands in 1986 to that in 1989?
Make the answer very short. 1.09. What is the ratio of the Grants(current US$) of Antigua and Barbuda in 1986 to that in 1990?
Offer a terse response. 0.37. What is the ratio of the Grants(current US$) of Cameroon in 1986 to that in 1990?
Make the answer very short. 0.19. What is the ratio of the Grants(current US$) of Saudi Arabia in 1986 to that in 1990?
Ensure brevity in your answer.  2.16. What is the ratio of the Grants(current US$) of Turks and Caicos Islands in 1986 to that in 1990?
Make the answer very short. 0.85. What is the ratio of the Grants(current US$) in Antigua and Barbuda in 1986 to that in 1991?
Make the answer very short. 0.23. What is the ratio of the Grants(current US$) of Cameroon in 1986 to that in 1991?
Keep it short and to the point. 0.23. What is the ratio of the Grants(current US$) in Saudi Arabia in 1986 to that in 1991?
Make the answer very short. 2.74. What is the ratio of the Grants(current US$) of Turks and Caicos Islands in 1986 to that in 1991?
Keep it short and to the point. 0.51. What is the ratio of the Grants(current US$) of Antigua and Barbuda in 1987 to that in 1988?
Offer a terse response. 0.41. What is the ratio of the Grants(current US$) of Cameroon in 1987 to that in 1988?
Ensure brevity in your answer.  0.81. What is the ratio of the Grants(current US$) in Saudi Arabia in 1987 to that in 1988?
Provide a short and direct response. 0.4. What is the ratio of the Grants(current US$) in Turks and Caicos Islands in 1987 to that in 1988?
Your response must be concise. 1.43. What is the ratio of the Grants(current US$) of Antigua and Barbuda in 1987 to that in 1989?
Your answer should be compact. 0.79. What is the ratio of the Grants(current US$) in Cameroon in 1987 to that in 1989?
Keep it short and to the point. 0.22. What is the ratio of the Grants(current US$) of Saudi Arabia in 1987 to that in 1989?
Your answer should be very brief. 1.53. What is the ratio of the Grants(current US$) of Turks and Caicos Islands in 1987 to that in 1989?
Your response must be concise. 1.2. What is the ratio of the Grants(current US$) in Antigua and Barbuda in 1987 to that in 1990?
Ensure brevity in your answer.  0.82. What is the ratio of the Grants(current US$) of Cameroon in 1987 to that in 1990?
Offer a terse response. 0.16. What is the ratio of the Grants(current US$) in Saudi Arabia in 1987 to that in 1990?
Your response must be concise. 2.81. What is the ratio of the Grants(current US$) in Turks and Caicos Islands in 1987 to that in 1990?
Provide a short and direct response. 0.94. What is the ratio of the Grants(current US$) in Antigua and Barbuda in 1987 to that in 1991?
Make the answer very short. 0.5. What is the ratio of the Grants(current US$) of Cameroon in 1987 to that in 1991?
Offer a very short reply. 0.19. What is the ratio of the Grants(current US$) of Saudi Arabia in 1987 to that in 1991?
Ensure brevity in your answer.  3.56. What is the ratio of the Grants(current US$) of Turks and Caicos Islands in 1987 to that in 1991?
Your response must be concise. 0.56. What is the ratio of the Grants(current US$) of Antigua and Barbuda in 1988 to that in 1989?
Give a very brief answer. 1.93. What is the ratio of the Grants(current US$) in Cameroon in 1988 to that in 1989?
Provide a short and direct response. 0.27. What is the ratio of the Grants(current US$) of Saudi Arabia in 1988 to that in 1989?
Your answer should be very brief. 3.84. What is the ratio of the Grants(current US$) of Turks and Caicos Islands in 1988 to that in 1989?
Your answer should be very brief. 0.84. What is the ratio of the Grants(current US$) of Antigua and Barbuda in 1988 to that in 1990?
Provide a short and direct response. 1.99. What is the ratio of the Grants(current US$) in Cameroon in 1988 to that in 1990?
Make the answer very short. 0.2. What is the ratio of the Grants(current US$) of Saudi Arabia in 1988 to that in 1990?
Give a very brief answer. 7.05. What is the ratio of the Grants(current US$) of Turks and Caicos Islands in 1988 to that in 1990?
Ensure brevity in your answer.  0.66. What is the ratio of the Grants(current US$) in Antigua and Barbuda in 1988 to that in 1991?
Ensure brevity in your answer.  1.22. What is the ratio of the Grants(current US$) in Cameroon in 1988 to that in 1991?
Offer a very short reply. 0.24. What is the ratio of the Grants(current US$) in Saudi Arabia in 1988 to that in 1991?
Give a very brief answer. 8.91. What is the ratio of the Grants(current US$) in Turks and Caicos Islands in 1988 to that in 1991?
Provide a succinct answer. 0.4. What is the ratio of the Grants(current US$) of Antigua and Barbuda in 1989 to that in 1990?
Provide a short and direct response. 1.03. What is the ratio of the Grants(current US$) of Cameroon in 1989 to that in 1990?
Keep it short and to the point. 0.72. What is the ratio of the Grants(current US$) in Saudi Arabia in 1989 to that in 1990?
Offer a very short reply. 1.84. What is the ratio of the Grants(current US$) in Turks and Caicos Islands in 1989 to that in 1990?
Your answer should be compact. 0.78. What is the ratio of the Grants(current US$) in Antigua and Barbuda in 1989 to that in 1991?
Provide a succinct answer. 0.63. What is the ratio of the Grants(current US$) in Cameroon in 1989 to that in 1991?
Offer a very short reply. 0.87. What is the ratio of the Grants(current US$) of Saudi Arabia in 1989 to that in 1991?
Your answer should be compact. 2.32. What is the ratio of the Grants(current US$) of Turks and Caicos Islands in 1989 to that in 1991?
Your answer should be compact. 0.47. What is the ratio of the Grants(current US$) of Antigua and Barbuda in 1990 to that in 1991?
Offer a terse response. 0.61. What is the ratio of the Grants(current US$) in Cameroon in 1990 to that in 1991?
Your response must be concise. 1.21. What is the ratio of the Grants(current US$) of Saudi Arabia in 1990 to that in 1991?
Give a very brief answer. 1.26. What is the ratio of the Grants(current US$) in Turks and Caicos Islands in 1990 to that in 1991?
Provide a succinct answer. 0.6. What is the difference between the highest and the second highest Grants(current US$) of Antigua and Barbuda?
Keep it short and to the point. 1.05e+06. What is the difference between the highest and the second highest Grants(current US$) in Cameroon?
Provide a succinct answer. 5.35e+07. What is the difference between the highest and the second highest Grants(current US$) in Saudi Arabia?
Make the answer very short. 1.82e+06. What is the difference between the highest and the second highest Grants(current US$) in Turks and Caicos Islands?
Make the answer very short. 4.94e+06. What is the difference between the highest and the lowest Grants(current US$) in Antigua and Barbuda?
Give a very brief answer. 5.24e+06. What is the difference between the highest and the lowest Grants(current US$) of Cameroon?
Make the answer very short. 2.69e+08. What is the difference between the highest and the lowest Grants(current US$) of Saudi Arabia?
Make the answer very short. 2.79e+06. What is the difference between the highest and the lowest Grants(current US$) in Turks and Caicos Islands?
Your response must be concise. 8.54e+06. 